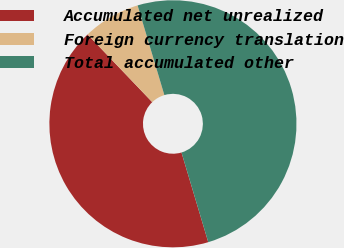<chart> <loc_0><loc_0><loc_500><loc_500><pie_chart><fcel>Accumulated net unrealized<fcel>Foreign currency translation<fcel>Total accumulated other<nl><fcel>42.48%<fcel>7.52%<fcel>50.0%<nl></chart> 